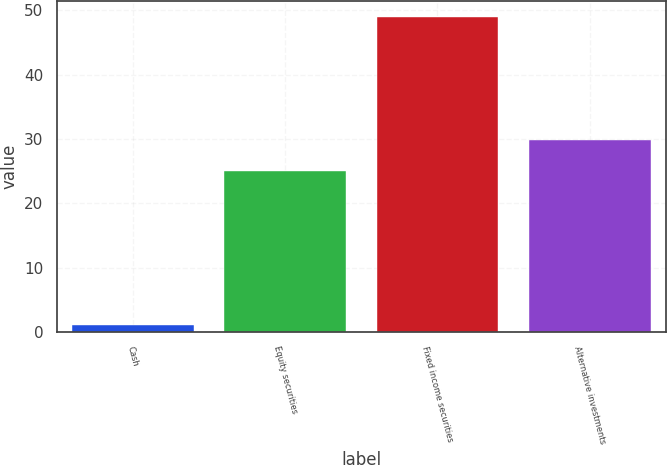Convert chart to OTSL. <chart><loc_0><loc_0><loc_500><loc_500><bar_chart><fcel>Cash<fcel>Equity securities<fcel>Fixed income securities<fcel>Alternative investments<nl><fcel>1<fcel>25<fcel>49<fcel>29.8<nl></chart> 